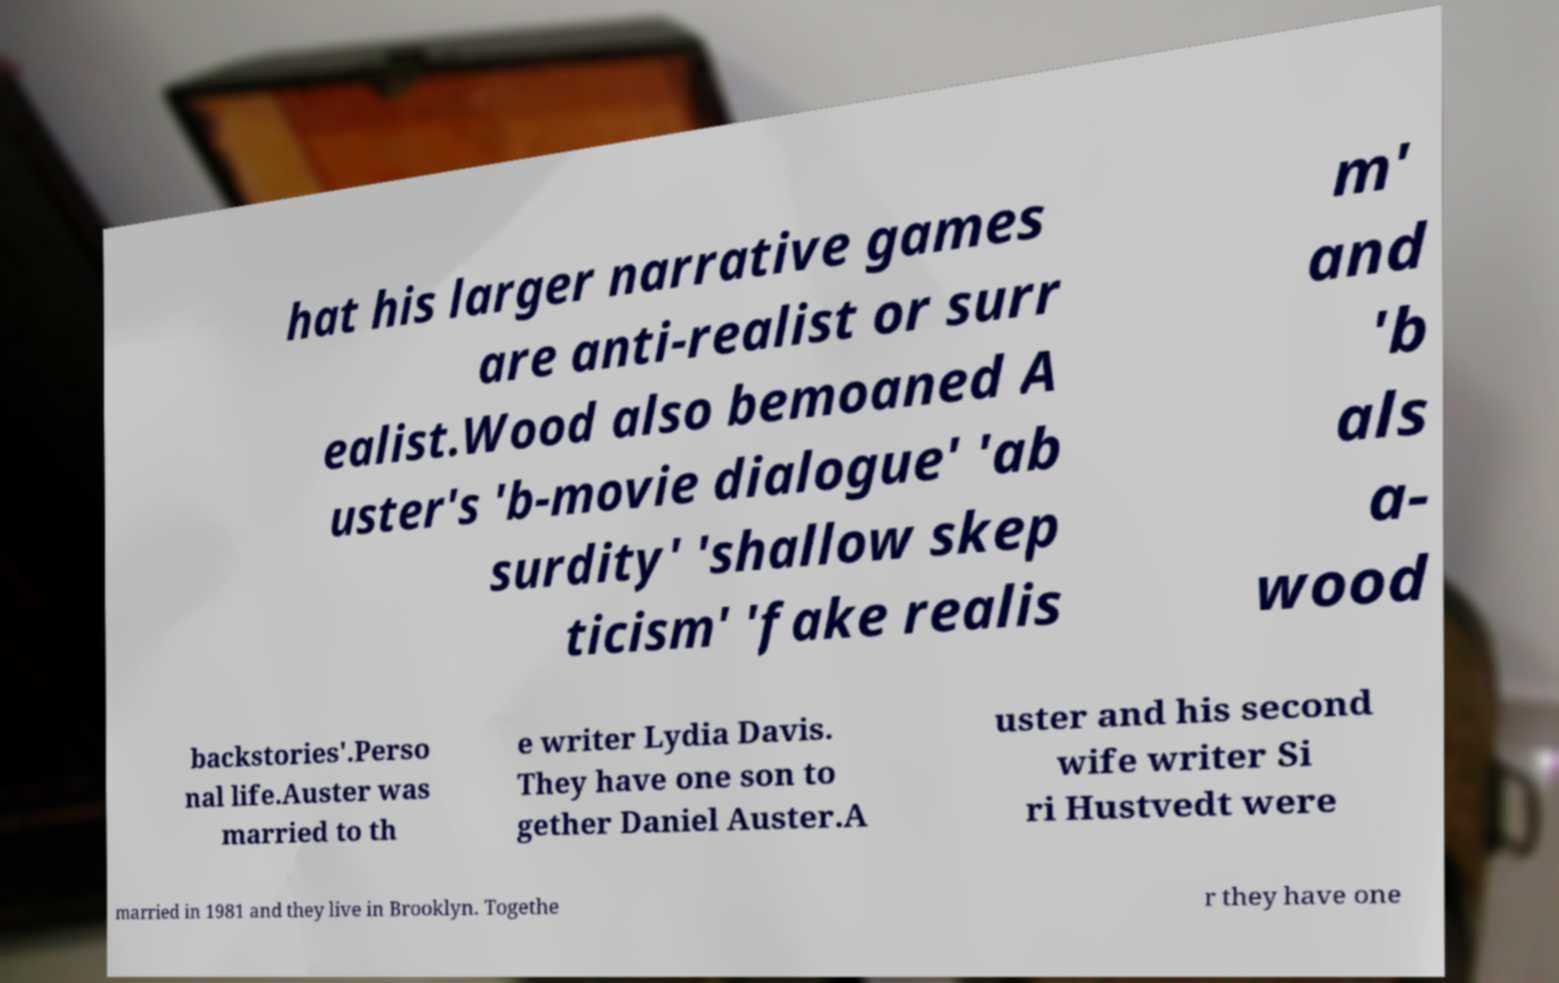I need the written content from this picture converted into text. Can you do that? hat his larger narrative games are anti-realist or surr ealist.Wood also bemoaned A uster's 'b-movie dialogue' 'ab surdity' 'shallow skep ticism' 'fake realis m' and 'b als a- wood backstories'.Perso nal life.Auster was married to th e writer Lydia Davis. They have one son to gether Daniel Auster.A uster and his second wife writer Si ri Hustvedt were married in 1981 and they live in Brooklyn. Togethe r they have one 